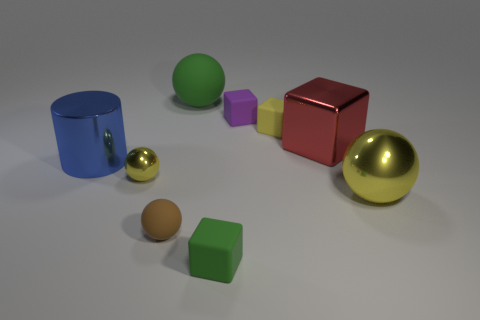Is there anything else that is the same color as the large shiny cube?
Give a very brief answer. No. What number of tiny green rubber things are there?
Ensure brevity in your answer.  1. The tiny ball in front of the large metal thing that is in front of the blue shiny object is made of what material?
Keep it short and to the point. Rubber. The rubber cube that is in front of the yellow shiny thing that is behind the yellow shiny sphere to the right of the tiny green rubber block is what color?
Your response must be concise. Green. Is the color of the metal cube the same as the large matte sphere?
Keep it short and to the point. No. What number of red things are the same size as the purple thing?
Offer a very short reply. 0. Are there more red metal objects that are to the left of the red thing than metallic balls that are behind the big blue metallic cylinder?
Your answer should be compact. No. There is a big sphere left of the ball right of the big green sphere; what is its color?
Make the answer very short. Green. Is the material of the large blue thing the same as the large yellow thing?
Make the answer very short. Yes. Are there any small shiny things that have the same shape as the purple rubber thing?
Your response must be concise. No. 